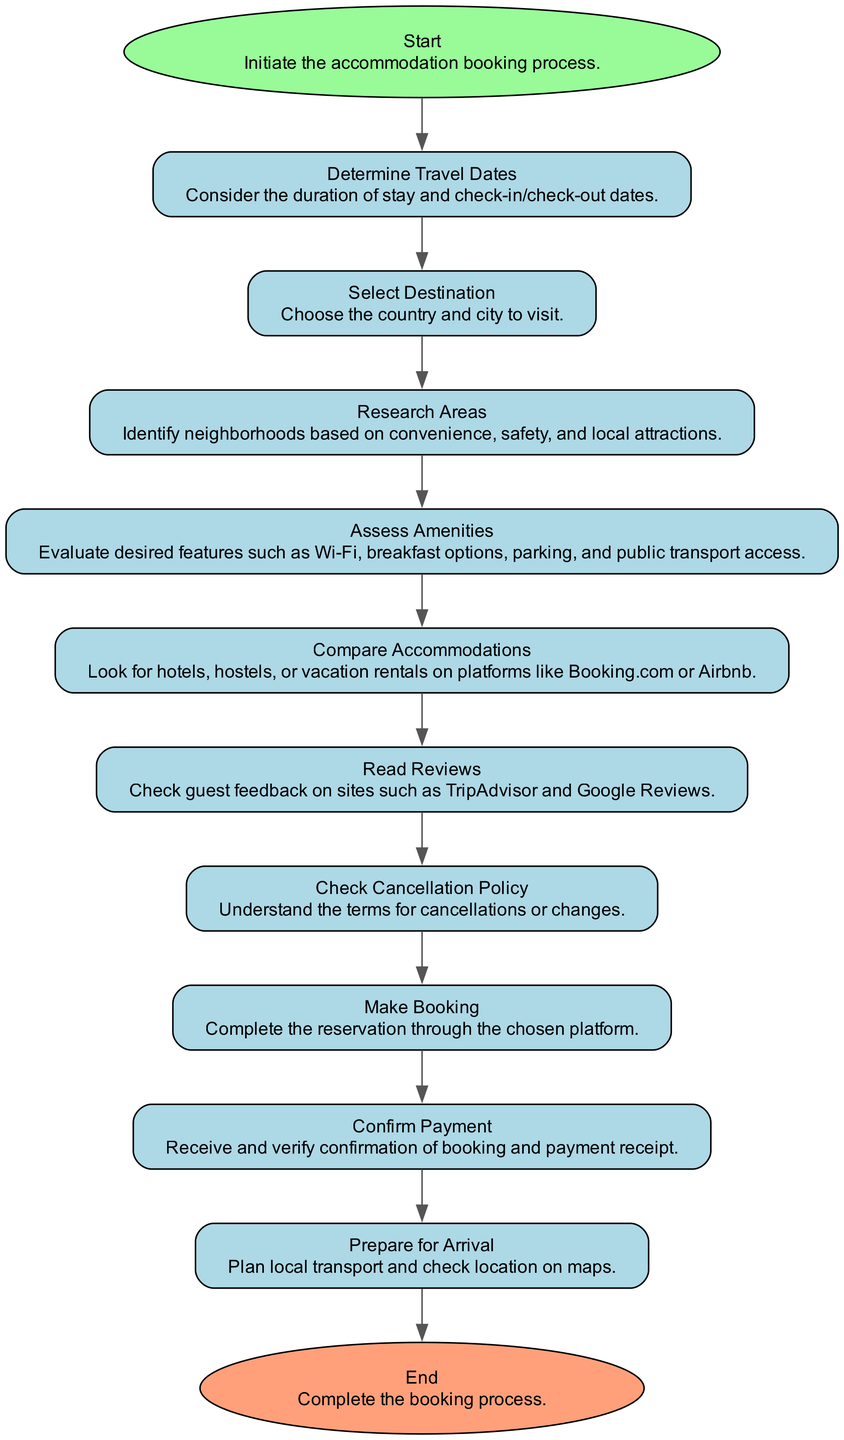What is the first step in the booking process? The diagram indicates that the first step in the booking process is labeled as "Start", which initiates the accommodation booking process.
Answer: Start How many steps are there in the diagram? Counting the nodes in the diagram reveals that there are 12 steps, including the Start and End nodes.
Answer: 12 What is the last step before making a booking? The diagram shows that the last step before making a booking is "Check Cancellation Policy", which details understanding the terms for cancellations or changes.
Answer: Check Cancellation Policy Which step involves evaluating desired features? The diagram indicates that "Assess Amenities" is the step where desired features such as Wi-Fi, breakfast, parking, and others are evaluated.
Answer: Assess Amenities How do you confirm the payment? According to the diagram, the step "Confirm Payment" involves verifying the confirmation of the booking and the payment receipt after making a booking.
Answer: Confirm Payment What is necessary to determine before selecting a destination? "Determine Travel Dates" is necessary before selecting a destination, as it involves considering the duration of stay and check-in/check-out dates.
Answer: Determine Travel Dates What step follows reading reviews? The diagram indicates that "Check Cancellation Policy" follows the step of "Read Reviews", which means the booking process continues with this consideration after checking guest feedback.
Answer: Check Cancellation Policy Which step assesses local attractions? The step "Research Areas" involves identifying neighborhoods based on convenience, safety, and local attractions, making it the one that assesses local attractions.
Answer: Research Areas What kind of platforms are used to compare accommodations? The diagram specifies that accommodations are compared on platforms like Booking.com or Airbnb, which are popular choices for travelers.
Answer: Booking.com or Airbnb 